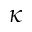Convert formula to latex. <formula><loc_0><loc_0><loc_500><loc_500>\kappa</formula> 